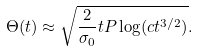<formula> <loc_0><loc_0><loc_500><loc_500>\Theta ( t ) \approx \sqrt { \frac { 2 } { \sigma _ { 0 } } t P \log ( c t ^ { 3 / 2 } ) } .</formula> 